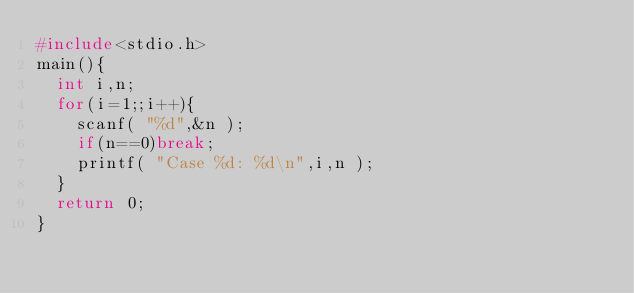<code> <loc_0><loc_0><loc_500><loc_500><_C_>#include<stdio.h>
main(){
  int i,n;
  for(i=1;;i++){
    scanf( "%d",&n );
    if(n==0)break;
    printf( "Case %d: %d\n",i,n );
  }
  return 0;
}
</code> 